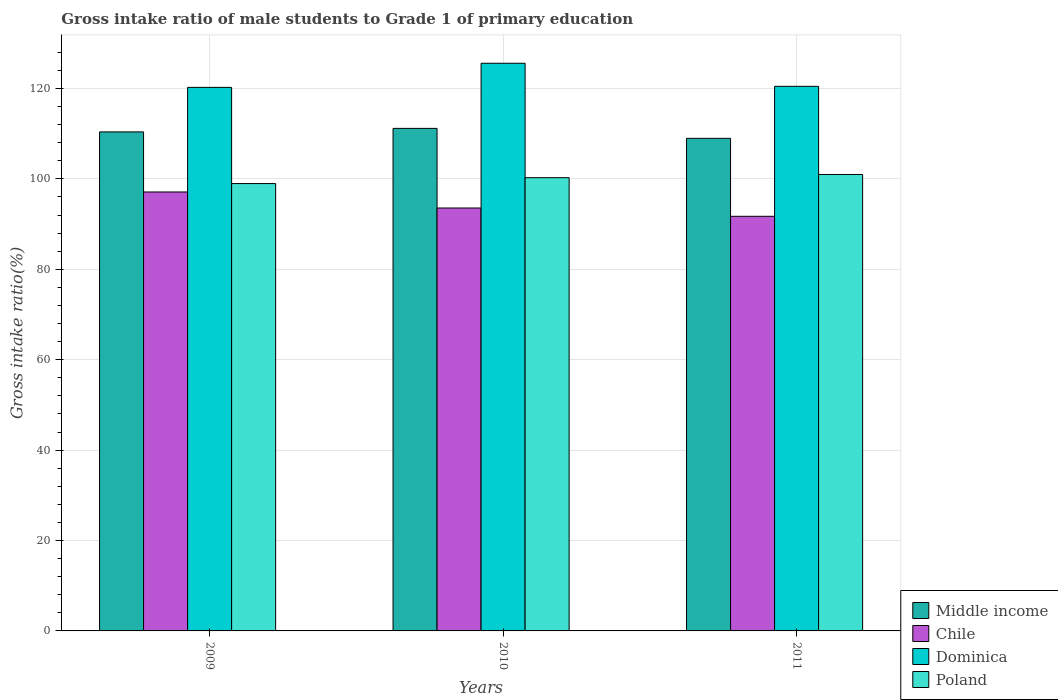How many different coloured bars are there?
Offer a very short reply. 4. How many groups of bars are there?
Your answer should be very brief. 3. Are the number of bars per tick equal to the number of legend labels?
Your response must be concise. Yes. How many bars are there on the 1st tick from the left?
Your response must be concise. 4. What is the gross intake ratio in Dominica in 2010?
Offer a very short reply. 125.58. Across all years, what is the maximum gross intake ratio in Dominica?
Provide a succinct answer. 125.58. Across all years, what is the minimum gross intake ratio in Middle income?
Your answer should be very brief. 108.97. In which year was the gross intake ratio in Dominica minimum?
Keep it short and to the point. 2009. What is the total gross intake ratio in Poland in the graph?
Offer a very short reply. 300.21. What is the difference between the gross intake ratio in Dominica in 2009 and that in 2010?
Keep it short and to the point. -5.34. What is the difference between the gross intake ratio in Middle income in 2011 and the gross intake ratio in Chile in 2010?
Offer a very short reply. 15.41. What is the average gross intake ratio in Poland per year?
Give a very brief answer. 100.07. In the year 2011, what is the difference between the gross intake ratio in Dominica and gross intake ratio in Poland?
Ensure brevity in your answer.  19.5. What is the ratio of the gross intake ratio in Chile in 2010 to that in 2011?
Your response must be concise. 1.02. Is the gross intake ratio in Middle income in 2009 less than that in 2011?
Offer a terse response. No. Is the difference between the gross intake ratio in Dominica in 2010 and 2011 greater than the difference between the gross intake ratio in Poland in 2010 and 2011?
Your answer should be very brief. Yes. What is the difference between the highest and the second highest gross intake ratio in Poland?
Make the answer very short. 0.71. What is the difference between the highest and the lowest gross intake ratio in Middle income?
Offer a very short reply. 2.2. In how many years, is the gross intake ratio in Dominica greater than the average gross intake ratio in Dominica taken over all years?
Provide a succinct answer. 1. What does the 3rd bar from the left in 2011 represents?
Offer a very short reply. Dominica. What does the 2nd bar from the right in 2010 represents?
Offer a very short reply. Dominica. Are all the bars in the graph horizontal?
Your response must be concise. No. Where does the legend appear in the graph?
Your response must be concise. Bottom right. How are the legend labels stacked?
Provide a succinct answer. Vertical. What is the title of the graph?
Provide a succinct answer. Gross intake ratio of male students to Grade 1 of primary education. What is the label or title of the Y-axis?
Your answer should be compact. Gross intake ratio(%). What is the Gross intake ratio(%) in Middle income in 2009?
Your answer should be compact. 110.4. What is the Gross intake ratio(%) of Chile in 2009?
Ensure brevity in your answer.  97.1. What is the Gross intake ratio(%) in Dominica in 2009?
Make the answer very short. 120.25. What is the Gross intake ratio(%) of Poland in 2009?
Your answer should be very brief. 98.96. What is the Gross intake ratio(%) of Middle income in 2010?
Your answer should be compact. 111.17. What is the Gross intake ratio(%) of Chile in 2010?
Provide a succinct answer. 93.56. What is the Gross intake ratio(%) in Dominica in 2010?
Provide a succinct answer. 125.58. What is the Gross intake ratio(%) in Poland in 2010?
Make the answer very short. 100.27. What is the Gross intake ratio(%) of Middle income in 2011?
Keep it short and to the point. 108.97. What is the Gross intake ratio(%) in Chile in 2011?
Offer a very short reply. 91.72. What is the Gross intake ratio(%) in Dominica in 2011?
Ensure brevity in your answer.  120.48. What is the Gross intake ratio(%) in Poland in 2011?
Provide a succinct answer. 100.98. Across all years, what is the maximum Gross intake ratio(%) of Middle income?
Your answer should be compact. 111.17. Across all years, what is the maximum Gross intake ratio(%) in Chile?
Provide a short and direct response. 97.1. Across all years, what is the maximum Gross intake ratio(%) of Dominica?
Your response must be concise. 125.58. Across all years, what is the maximum Gross intake ratio(%) in Poland?
Offer a very short reply. 100.98. Across all years, what is the minimum Gross intake ratio(%) of Middle income?
Offer a terse response. 108.97. Across all years, what is the minimum Gross intake ratio(%) in Chile?
Provide a succinct answer. 91.72. Across all years, what is the minimum Gross intake ratio(%) in Dominica?
Offer a very short reply. 120.25. Across all years, what is the minimum Gross intake ratio(%) in Poland?
Provide a succinct answer. 98.96. What is the total Gross intake ratio(%) in Middle income in the graph?
Your response must be concise. 330.54. What is the total Gross intake ratio(%) of Chile in the graph?
Your response must be concise. 282.39. What is the total Gross intake ratio(%) of Dominica in the graph?
Offer a terse response. 366.31. What is the total Gross intake ratio(%) in Poland in the graph?
Give a very brief answer. 300.21. What is the difference between the Gross intake ratio(%) of Middle income in 2009 and that in 2010?
Offer a terse response. -0.78. What is the difference between the Gross intake ratio(%) of Chile in 2009 and that in 2010?
Keep it short and to the point. 3.55. What is the difference between the Gross intake ratio(%) in Dominica in 2009 and that in 2010?
Make the answer very short. -5.34. What is the difference between the Gross intake ratio(%) in Poland in 2009 and that in 2010?
Your answer should be compact. -1.3. What is the difference between the Gross intake ratio(%) of Middle income in 2009 and that in 2011?
Offer a very short reply. 1.43. What is the difference between the Gross intake ratio(%) in Chile in 2009 and that in 2011?
Your response must be concise. 5.38. What is the difference between the Gross intake ratio(%) of Dominica in 2009 and that in 2011?
Keep it short and to the point. -0.23. What is the difference between the Gross intake ratio(%) of Poland in 2009 and that in 2011?
Provide a succinct answer. -2.01. What is the difference between the Gross intake ratio(%) in Middle income in 2010 and that in 2011?
Offer a very short reply. 2.2. What is the difference between the Gross intake ratio(%) in Chile in 2010 and that in 2011?
Give a very brief answer. 1.83. What is the difference between the Gross intake ratio(%) of Dominica in 2010 and that in 2011?
Provide a short and direct response. 5.1. What is the difference between the Gross intake ratio(%) in Poland in 2010 and that in 2011?
Make the answer very short. -0.71. What is the difference between the Gross intake ratio(%) in Middle income in 2009 and the Gross intake ratio(%) in Chile in 2010?
Provide a short and direct response. 16.84. What is the difference between the Gross intake ratio(%) in Middle income in 2009 and the Gross intake ratio(%) in Dominica in 2010?
Your answer should be compact. -15.18. What is the difference between the Gross intake ratio(%) in Middle income in 2009 and the Gross intake ratio(%) in Poland in 2010?
Your answer should be compact. 10.13. What is the difference between the Gross intake ratio(%) of Chile in 2009 and the Gross intake ratio(%) of Dominica in 2010?
Provide a succinct answer. -28.48. What is the difference between the Gross intake ratio(%) in Chile in 2009 and the Gross intake ratio(%) in Poland in 2010?
Keep it short and to the point. -3.16. What is the difference between the Gross intake ratio(%) in Dominica in 2009 and the Gross intake ratio(%) in Poland in 2010?
Your answer should be very brief. 19.98. What is the difference between the Gross intake ratio(%) of Middle income in 2009 and the Gross intake ratio(%) of Chile in 2011?
Your answer should be compact. 18.67. What is the difference between the Gross intake ratio(%) in Middle income in 2009 and the Gross intake ratio(%) in Dominica in 2011?
Make the answer very short. -10.08. What is the difference between the Gross intake ratio(%) of Middle income in 2009 and the Gross intake ratio(%) of Poland in 2011?
Provide a succinct answer. 9.42. What is the difference between the Gross intake ratio(%) in Chile in 2009 and the Gross intake ratio(%) in Dominica in 2011?
Offer a very short reply. -23.37. What is the difference between the Gross intake ratio(%) of Chile in 2009 and the Gross intake ratio(%) of Poland in 2011?
Offer a very short reply. -3.87. What is the difference between the Gross intake ratio(%) in Dominica in 2009 and the Gross intake ratio(%) in Poland in 2011?
Offer a very short reply. 19.27. What is the difference between the Gross intake ratio(%) in Middle income in 2010 and the Gross intake ratio(%) in Chile in 2011?
Your response must be concise. 19.45. What is the difference between the Gross intake ratio(%) in Middle income in 2010 and the Gross intake ratio(%) in Dominica in 2011?
Your answer should be very brief. -9.31. What is the difference between the Gross intake ratio(%) in Middle income in 2010 and the Gross intake ratio(%) in Poland in 2011?
Your response must be concise. 10.2. What is the difference between the Gross intake ratio(%) in Chile in 2010 and the Gross intake ratio(%) in Dominica in 2011?
Offer a very short reply. -26.92. What is the difference between the Gross intake ratio(%) of Chile in 2010 and the Gross intake ratio(%) of Poland in 2011?
Keep it short and to the point. -7.42. What is the difference between the Gross intake ratio(%) in Dominica in 2010 and the Gross intake ratio(%) in Poland in 2011?
Provide a short and direct response. 24.61. What is the average Gross intake ratio(%) of Middle income per year?
Provide a short and direct response. 110.18. What is the average Gross intake ratio(%) of Chile per year?
Your response must be concise. 94.13. What is the average Gross intake ratio(%) in Dominica per year?
Give a very brief answer. 122.1. What is the average Gross intake ratio(%) of Poland per year?
Ensure brevity in your answer.  100.07. In the year 2009, what is the difference between the Gross intake ratio(%) in Middle income and Gross intake ratio(%) in Chile?
Offer a terse response. 13.29. In the year 2009, what is the difference between the Gross intake ratio(%) in Middle income and Gross intake ratio(%) in Dominica?
Make the answer very short. -9.85. In the year 2009, what is the difference between the Gross intake ratio(%) of Middle income and Gross intake ratio(%) of Poland?
Your response must be concise. 11.43. In the year 2009, what is the difference between the Gross intake ratio(%) of Chile and Gross intake ratio(%) of Dominica?
Offer a terse response. -23.14. In the year 2009, what is the difference between the Gross intake ratio(%) in Chile and Gross intake ratio(%) in Poland?
Make the answer very short. -1.86. In the year 2009, what is the difference between the Gross intake ratio(%) in Dominica and Gross intake ratio(%) in Poland?
Your answer should be very brief. 21.28. In the year 2010, what is the difference between the Gross intake ratio(%) in Middle income and Gross intake ratio(%) in Chile?
Make the answer very short. 17.61. In the year 2010, what is the difference between the Gross intake ratio(%) in Middle income and Gross intake ratio(%) in Dominica?
Your response must be concise. -14.41. In the year 2010, what is the difference between the Gross intake ratio(%) of Middle income and Gross intake ratio(%) of Poland?
Provide a short and direct response. 10.9. In the year 2010, what is the difference between the Gross intake ratio(%) in Chile and Gross intake ratio(%) in Dominica?
Provide a short and direct response. -32.02. In the year 2010, what is the difference between the Gross intake ratio(%) in Chile and Gross intake ratio(%) in Poland?
Offer a terse response. -6.71. In the year 2010, what is the difference between the Gross intake ratio(%) in Dominica and Gross intake ratio(%) in Poland?
Offer a terse response. 25.31. In the year 2011, what is the difference between the Gross intake ratio(%) of Middle income and Gross intake ratio(%) of Chile?
Provide a short and direct response. 17.25. In the year 2011, what is the difference between the Gross intake ratio(%) of Middle income and Gross intake ratio(%) of Dominica?
Your answer should be very brief. -11.51. In the year 2011, what is the difference between the Gross intake ratio(%) of Middle income and Gross intake ratio(%) of Poland?
Keep it short and to the point. 7.99. In the year 2011, what is the difference between the Gross intake ratio(%) in Chile and Gross intake ratio(%) in Dominica?
Your response must be concise. -28.75. In the year 2011, what is the difference between the Gross intake ratio(%) in Chile and Gross intake ratio(%) in Poland?
Offer a very short reply. -9.25. In the year 2011, what is the difference between the Gross intake ratio(%) of Dominica and Gross intake ratio(%) of Poland?
Offer a very short reply. 19.5. What is the ratio of the Gross intake ratio(%) of Middle income in 2009 to that in 2010?
Your answer should be very brief. 0.99. What is the ratio of the Gross intake ratio(%) of Chile in 2009 to that in 2010?
Offer a terse response. 1.04. What is the ratio of the Gross intake ratio(%) of Dominica in 2009 to that in 2010?
Make the answer very short. 0.96. What is the ratio of the Gross intake ratio(%) in Poland in 2009 to that in 2010?
Your response must be concise. 0.99. What is the ratio of the Gross intake ratio(%) of Middle income in 2009 to that in 2011?
Provide a succinct answer. 1.01. What is the ratio of the Gross intake ratio(%) of Chile in 2009 to that in 2011?
Your response must be concise. 1.06. What is the ratio of the Gross intake ratio(%) of Poland in 2009 to that in 2011?
Make the answer very short. 0.98. What is the ratio of the Gross intake ratio(%) in Middle income in 2010 to that in 2011?
Your answer should be very brief. 1.02. What is the ratio of the Gross intake ratio(%) in Chile in 2010 to that in 2011?
Make the answer very short. 1.02. What is the ratio of the Gross intake ratio(%) in Dominica in 2010 to that in 2011?
Ensure brevity in your answer.  1.04. What is the difference between the highest and the second highest Gross intake ratio(%) of Middle income?
Offer a very short reply. 0.78. What is the difference between the highest and the second highest Gross intake ratio(%) of Chile?
Keep it short and to the point. 3.55. What is the difference between the highest and the second highest Gross intake ratio(%) in Dominica?
Provide a succinct answer. 5.1. What is the difference between the highest and the second highest Gross intake ratio(%) in Poland?
Offer a very short reply. 0.71. What is the difference between the highest and the lowest Gross intake ratio(%) in Middle income?
Provide a succinct answer. 2.2. What is the difference between the highest and the lowest Gross intake ratio(%) of Chile?
Give a very brief answer. 5.38. What is the difference between the highest and the lowest Gross intake ratio(%) of Dominica?
Your answer should be very brief. 5.34. What is the difference between the highest and the lowest Gross intake ratio(%) of Poland?
Your answer should be very brief. 2.01. 